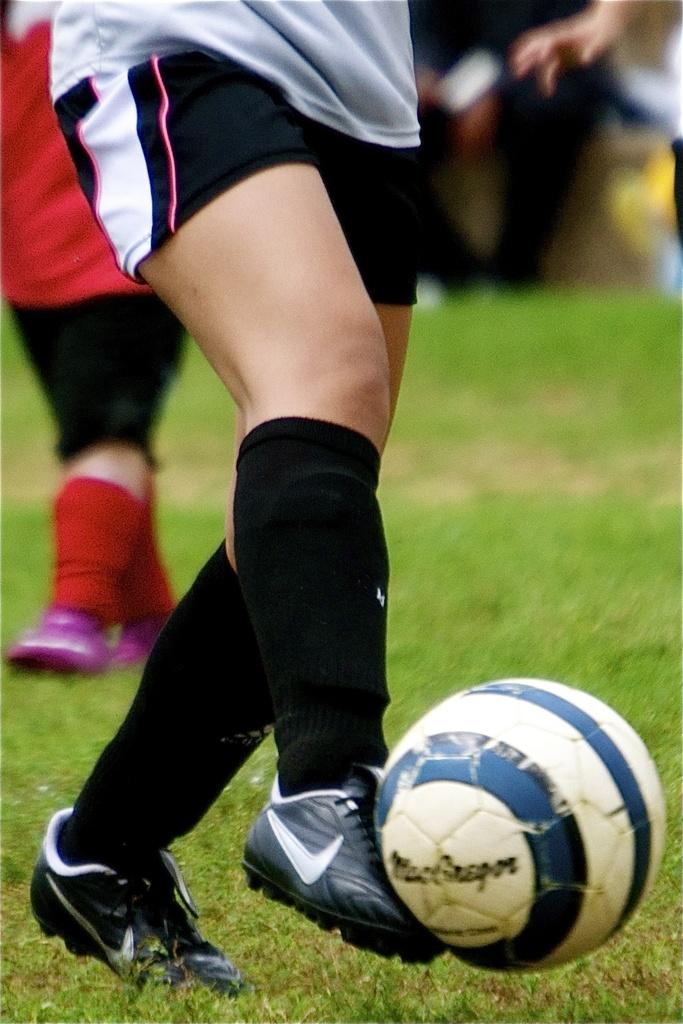What is the main action taking place in the image? There is a person's leg kicking a football in the image. Can you describe any other people in the image? There are legs of another person visible in the image. What is the background of the image like? The background of the image is blurred. What type of joke is being told by the person with the burning screw in the image? There is no person with a burning screw in the image, nor is there any indication of a joke being told. 